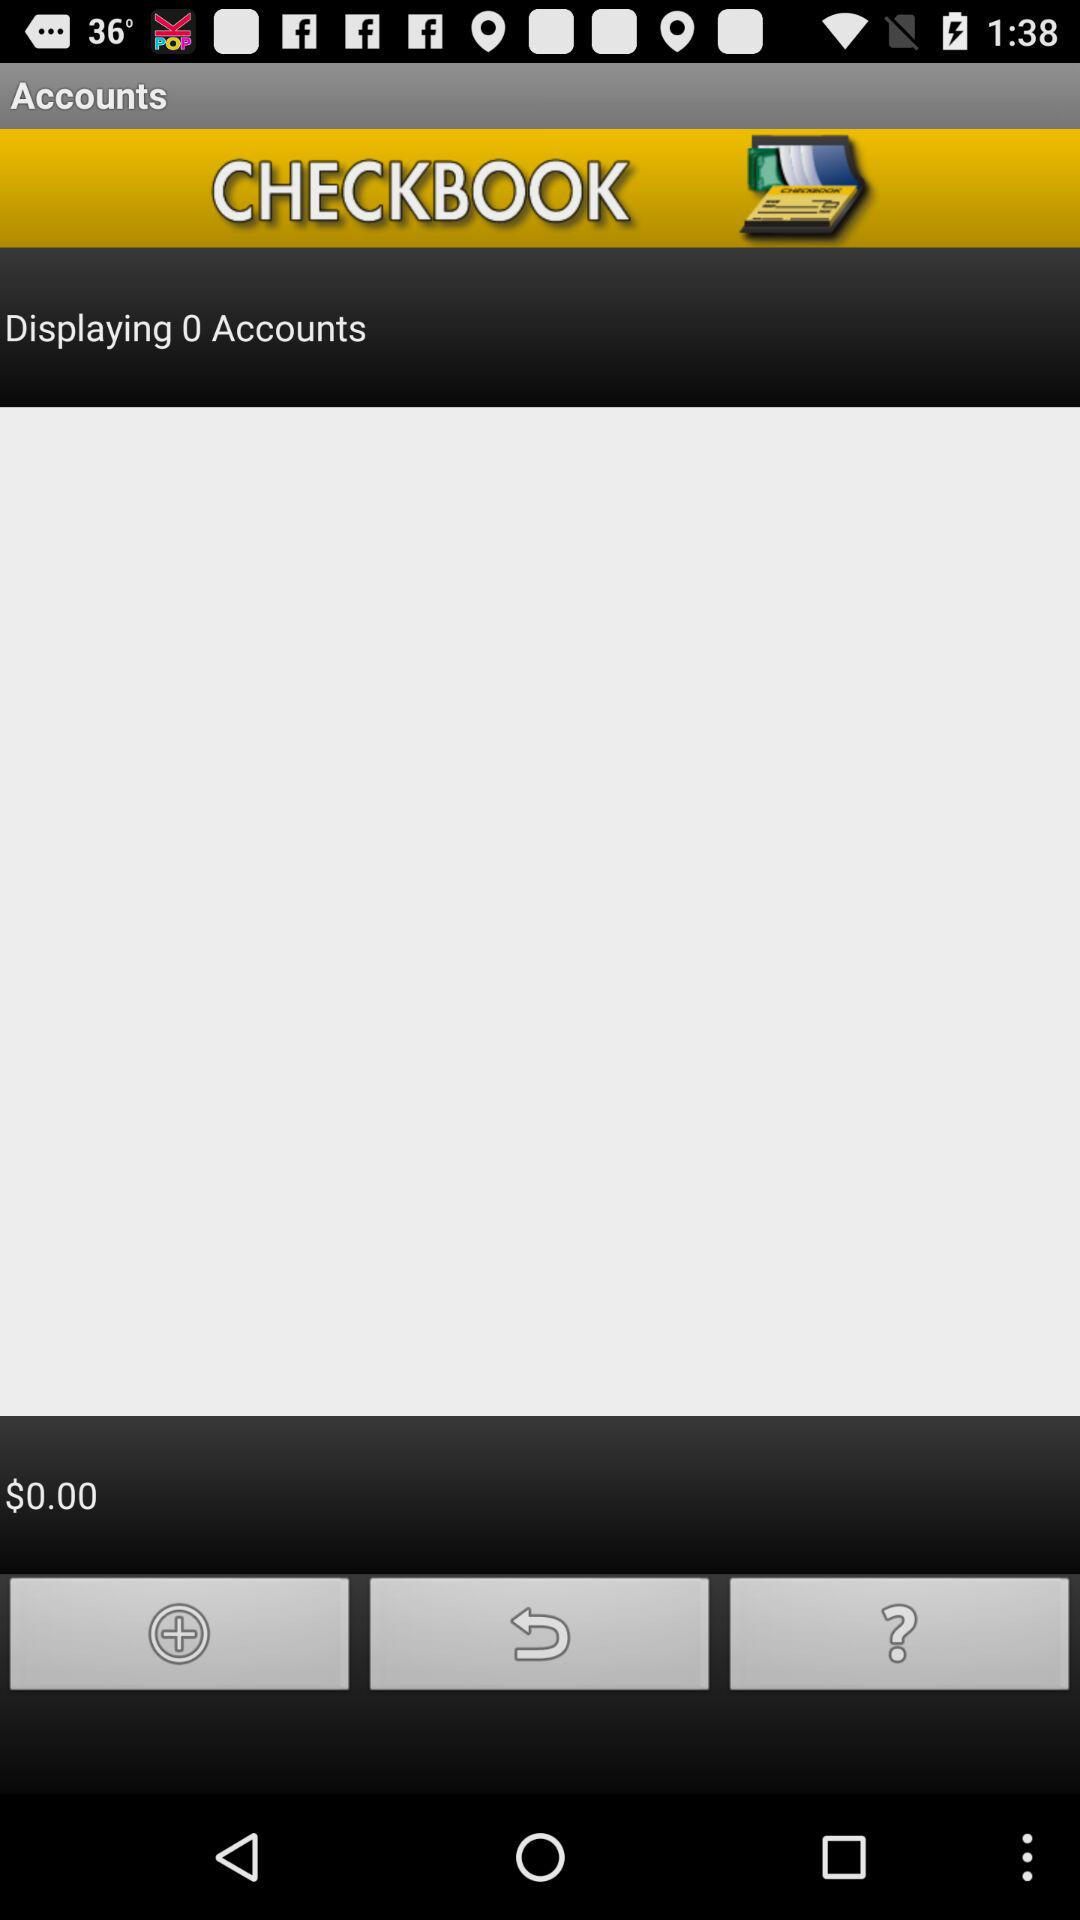What is the total checkbook amount? The total checkbook amount is $0. 